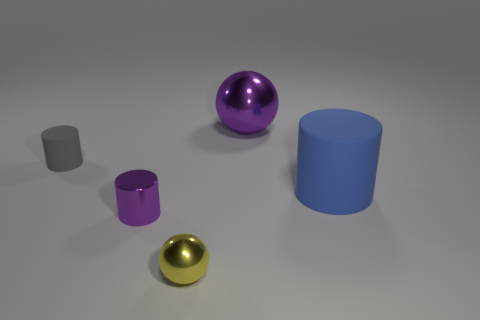Add 3 big blue matte cubes. How many objects exist? 8 Subtract all cylinders. How many objects are left? 2 Add 3 gray things. How many gray things exist? 4 Subtract 1 purple cylinders. How many objects are left? 4 Subtract all purple matte cubes. Subtract all matte objects. How many objects are left? 3 Add 2 tiny matte things. How many tiny matte things are left? 3 